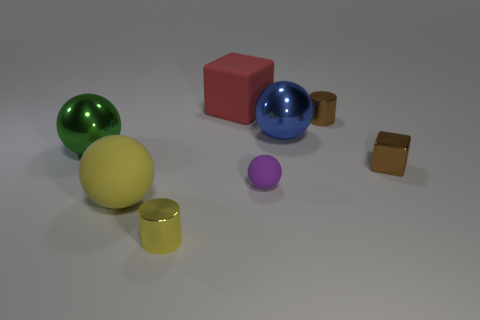There is a green metal sphere behind the small cylinder that is in front of the large blue sphere; how big is it?
Keep it short and to the point. Large. Is there anything else that is the same shape as the large yellow thing?
Your answer should be very brief. Yes. Is the number of large green things less than the number of tiny yellow metal spheres?
Provide a short and direct response. No. There is a big sphere that is on the left side of the tiny purple rubber ball and behind the big yellow matte thing; what material is it made of?
Offer a very short reply. Metal. There is a small cylinder behind the green sphere; are there any tiny spheres that are in front of it?
Provide a short and direct response. Yes. What number of objects are small red matte cylinders or metallic objects?
Keep it short and to the point. 5. What shape is the shiny object that is both on the left side of the big block and behind the yellow metallic cylinder?
Offer a terse response. Sphere. Do the cube behind the green sphere and the green sphere have the same material?
Your answer should be very brief. No. How many things are either yellow cylinders or shiny balls that are on the left side of the red block?
Ensure brevity in your answer.  2. There is a tiny block that is made of the same material as the big green object; what is its color?
Keep it short and to the point. Brown. 